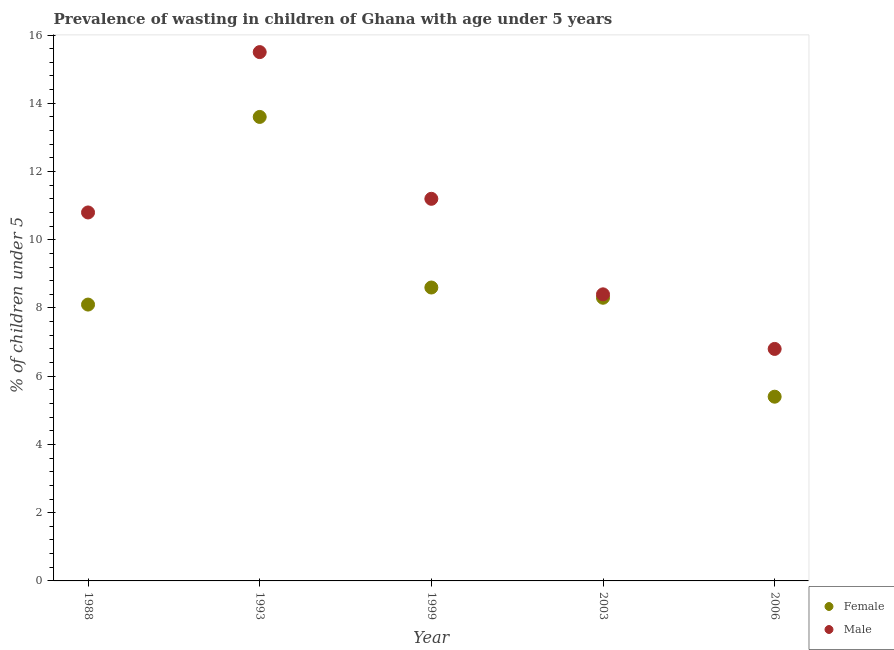What is the percentage of undernourished male children in 2003?
Give a very brief answer. 8.4. Across all years, what is the maximum percentage of undernourished female children?
Keep it short and to the point. 13.6. Across all years, what is the minimum percentage of undernourished male children?
Give a very brief answer. 6.8. What is the total percentage of undernourished female children in the graph?
Your response must be concise. 44. What is the difference between the percentage of undernourished female children in 1993 and that in 2006?
Your answer should be compact. 8.2. What is the difference between the percentage of undernourished male children in 2003 and the percentage of undernourished female children in 1999?
Keep it short and to the point. -0.2. What is the average percentage of undernourished male children per year?
Provide a succinct answer. 10.54. In the year 2003, what is the difference between the percentage of undernourished female children and percentage of undernourished male children?
Make the answer very short. -0.1. In how many years, is the percentage of undernourished female children greater than 11.2 %?
Provide a short and direct response. 1. What is the ratio of the percentage of undernourished female children in 1988 to that in 1993?
Your answer should be very brief. 0.6. Is the difference between the percentage of undernourished male children in 1999 and 2003 greater than the difference between the percentage of undernourished female children in 1999 and 2003?
Offer a very short reply. Yes. What is the difference between the highest and the second highest percentage of undernourished male children?
Offer a very short reply. 4.3. What is the difference between the highest and the lowest percentage of undernourished female children?
Your response must be concise. 8.2. Is the sum of the percentage of undernourished female children in 1993 and 2006 greater than the maximum percentage of undernourished male children across all years?
Offer a terse response. Yes. Is the percentage of undernourished female children strictly less than the percentage of undernourished male children over the years?
Provide a short and direct response. Yes. How many years are there in the graph?
Your answer should be very brief. 5. What is the difference between two consecutive major ticks on the Y-axis?
Provide a succinct answer. 2. Are the values on the major ticks of Y-axis written in scientific E-notation?
Offer a terse response. No. Does the graph contain grids?
Ensure brevity in your answer.  No. Where does the legend appear in the graph?
Offer a very short reply. Bottom right. What is the title of the graph?
Your response must be concise. Prevalence of wasting in children of Ghana with age under 5 years. Does "Money lenders" appear as one of the legend labels in the graph?
Offer a terse response. No. What is the label or title of the Y-axis?
Your answer should be very brief.  % of children under 5. What is the  % of children under 5 of Female in 1988?
Your answer should be very brief. 8.1. What is the  % of children under 5 of Male in 1988?
Your answer should be very brief. 10.8. What is the  % of children under 5 in Female in 1993?
Offer a very short reply. 13.6. What is the  % of children under 5 in Female in 1999?
Your answer should be compact. 8.6. What is the  % of children under 5 of Male in 1999?
Keep it short and to the point. 11.2. What is the  % of children under 5 of Female in 2003?
Offer a very short reply. 8.3. What is the  % of children under 5 in Male in 2003?
Provide a short and direct response. 8.4. What is the  % of children under 5 in Female in 2006?
Make the answer very short. 5.4. What is the  % of children under 5 of Male in 2006?
Your response must be concise. 6.8. Across all years, what is the maximum  % of children under 5 in Female?
Provide a succinct answer. 13.6. Across all years, what is the minimum  % of children under 5 in Female?
Provide a succinct answer. 5.4. Across all years, what is the minimum  % of children under 5 in Male?
Make the answer very short. 6.8. What is the total  % of children under 5 in Male in the graph?
Provide a succinct answer. 52.7. What is the difference between the  % of children under 5 in Male in 1988 and that in 1993?
Your answer should be very brief. -4.7. What is the difference between the  % of children under 5 in Female in 1988 and that in 1999?
Make the answer very short. -0.5. What is the difference between the  % of children under 5 in Female in 1988 and that in 2006?
Offer a very short reply. 2.7. What is the difference between the  % of children under 5 in Female in 1993 and that in 1999?
Your response must be concise. 5. What is the difference between the  % of children under 5 of Male in 1993 and that in 1999?
Provide a short and direct response. 4.3. What is the difference between the  % of children under 5 of Female in 1993 and that in 2003?
Ensure brevity in your answer.  5.3. What is the difference between the  % of children under 5 of Male in 1993 and that in 2003?
Offer a very short reply. 7.1. What is the difference between the  % of children under 5 of Female in 1993 and that in 2006?
Offer a terse response. 8.2. What is the difference between the  % of children under 5 of Male in 1999 and that in 2003?
Make the answer very short. 2.8. What is the difference between the  % of children under 5 of Male in 1999 and that in 2006?
Keep it short and to the point. 4.4. What is the difference between the  % of children under 5 of Male in 2003 and that in 2006?
Your answer should be very brief. 1.6. What is the difference between the  % of children under 5 in Female in 1988 and the  % of children under 5 in Male in 1993?
Give a very brief answer. -7.4. What is the difference between the  % of children under 5 of Female in 1988 and the  % of children under 5 of Male in 1999?
Offer a terse response. -3.1. What is the difference between the  % of children under 5 in Female in 1988 and the  % of children under 5 in Male in 2006?
Offer a terse response. 1.3. What is the difference between the  % of children under 5 of Female in 1993 and the  % of children under 5 of Male in 1999?
Give a very brief answer. 2.4. What is the difference between the  % of children under 5 of Female in 1993 and the  % of children under 5 of Male in 2003?
Give a very brief answer. 5.2. What is the difference between the  % of children under 5 in Female in 1999 and the  % of children under 5 in Male in 2003?
Keep it short and to the point. 0.2. What is the difference between the  % of children under 5 of Female in 1999 and the  % of children under 5 of Male in 2006?
Make the answer very short. 1.8. What is the average  % of children under 5 of Male per year?
Ensure brevity in your answer.  10.54. In the year 2003, what is the difference between the  % of children under 5 in Female and  % of children under 5 in Male?
Provide a succinct answer. -0.1. What is the ratio of the  % of children under 5 in Female in 1988 to that in 1993?
Offer a very short reply. 0.6. What is the ratio of the  % of children under 5 of Male in 1988 to that in 1993?
Provide a succinct answer. 0.7. What is the ratio of the  % of children under 5 in Female in 1988 to that in 1999?
Your response must be concise. 0.94. What is the ratio of the  % of children under 5 of Male in 1988 to that in 1999?
Offer a very short reply. 0.96. What is the ratio of the  % of children under 5 in Female in 1988 to that in 2003?
Your answer should be very brief. 0.98. What is the ratio of the  % of children under 5 of Male in 1988 to that in 2003?
Offer a very short reply. 1.29. What is the ratio of the  % of children under 5 of Male in 1988 to that in 2006?
Provide a succinct answer. 1.59. What is the ratio of the  % of children under 5 of Female in 1993 to that in 1999?
Keep it short and to the point. 1.58. What is the ratio of the  % of children under 5 in Male in 1993 to that in 1999?
Offer a very short reply. 1.38. What is the ratio of the  % of children under 5 of Female in 1993 to that in 2003?
Offer a terse response. 1.64. What is the ratio of the  % of children under 5 in Male in 1993 to that in 2003?
Provide a succinct answer. 1.85. What is the ratio of the  % of children under 5 in Female in 1993 to that in 2006?
Offer a terse response. 2.52. What is the ratio of the  % of children under 5 of Male in 1993 to that in 2006?
Your answer should be very brief. 2.28. What is the ratio of the  % of children under 5 of Female in 1999 to that in 2003?
Provide a succinct answer. 1.04. What is the ratio of the  % of children under 5 of Female in 1999 to that in 2006?
Provide a short and direct response. 1.59. What is the ratio of the  % of children under 5 of Male in 1999 to that in 2006?
Your answer should be very brief. 1.65. What is the ratio of the  % of children under 5 of Female in 2003 to that in 2006?
Your answer should be very brief. 1.54. What is the ratio of the  % of children under 5 in Male in 2003 to that in 2006?
Ensure brevity in your answer.  1.24. What is the difference between the highest and the second highest  % of children under 5 of Male?
Give a very brief answer. 4.3. 